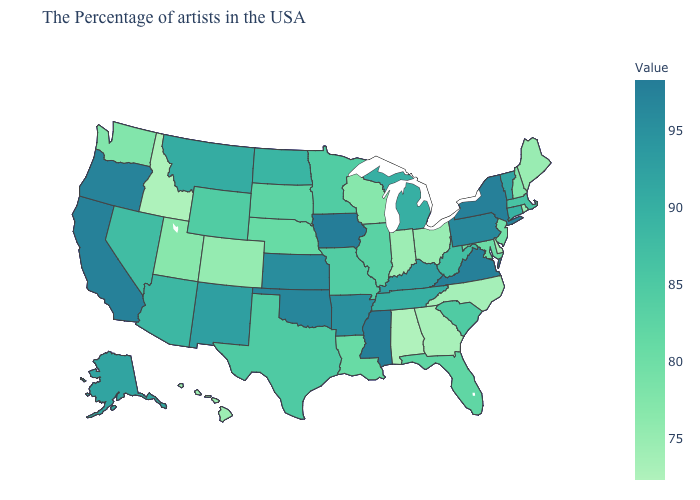Which states have the highest value in the USA?
Answer briefly. Iowa. Does Vermont have a lower value than Maine?
Quick response, please. No. Does Tennessee have a higher value than Nebraska?
Concise answer only. Yes. Among the states that border South Dakota , does Nebraska have the lowest value?
Be succinct. Yes. 